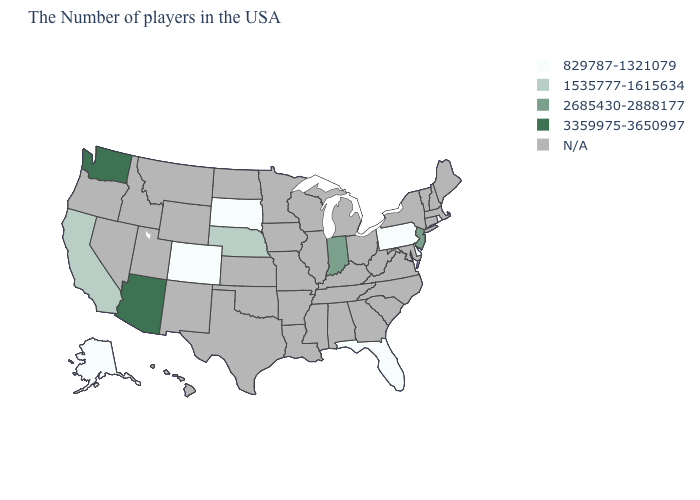What is the value of Kansas?
Concise answer only. N/A. What is the value of California?
Be succinct. 1535777-1615634. Name the states that have a value in the range 1535777-1615634?
Short answer required. Nebraska, California. What is the value of Colorado?
Be succinct. 829787-1321079. Name the states that have a value in the range 1535777-1615634?
Concise answer only. Nebraska, California. What is the highest value in the USA?
Be succinct. 3359975-3650997. What is the lowest value in the MidWest?
Short answer required. 829787-1321079. What is the highest value in the USA?
Be succinct. 3359975-3650997. What is the highest value in the Northeast ?
Write a very short answer. 2685430-2888177. What is the value of Louisiana?
Keep it brief. N/A. Which states have the lowest value in the USA?
Concise answer only. Rhode Island, Delaware, Pennsylvania, Florida, South Dakota, Colorado, Alaska. 